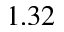<formula> <loc_0><loc_0><loc_500><loc_500>1 . 3 2</formula> 